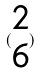<formula> <loc_0><loc_0><loc_500><loc_500>( \begin{matrix} 2 \\ 6 \end{matrix} )</formula> 